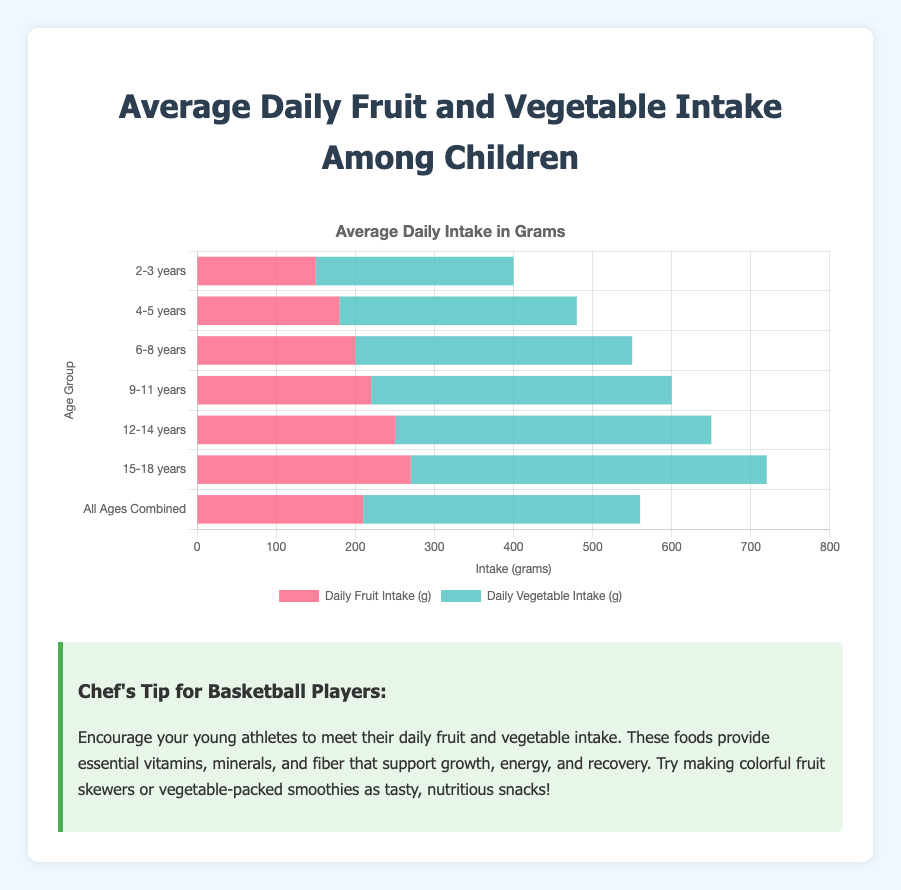What is the total daily intake (fruits and vegetables combined) for children aged 6-8 years? Sum the daily fruit intake (200 g) and daily vegetable intake (350 g) for children aged 6-8 years. 200 g + 350 g = 550 g
Answer: 550 g Which age group has the highest daily fruit intake? Check the daily fruit intake values for all age groups and identify the highest value, which is 270 g for the 15-18 years age group.
Answer: 15-18 years Between the 2-3 years and 4-5 years age groups, which has a higher vegetable intake? Compare the daily vegetable intake for the 2-3 years age group (250 g) and the 4-5 years age group (300 g). 300 g is greater than 250 g.
Answer: 4-5 years What is the visual difference in daily fruit intake between the 9-11 years and 12-14 years age groups? From the chart, compare the lengths of the bars representing fruit intake for 9-11 years (220 g) and 12-14 years (250 g). The difference is 250 g - 220 g = 30 g.
Answer: 30 g What is the average daily vegetable intake for all ages combined? The daily vegetable intake for all ages combined is given as 350 g.
Answer: 350 g Which age group's total daily intake (fruits and vegetables) is closest to 600 grams? Add the daily fruit and vegetable intake for each age group and compare the sums: 2-3 years = 400 g, 4-5 years = 480 g, 6-8 years = 550 g, 9-11 years = 600 g, 12-14 years = 650 g, 15-18 years = 720 g. 9-11 years total (600 g) is closest to 600 grams.
Answer: 9-11 years Is the daily fruit intake higher or lower than the daily vegetable intake for children aged 2-3 years? Compare the daily fruit intake (150 g) and vegetable intake (250 g) for the 2-3 years age group. 150 g is less than 250 g.
Answer: Lower How does the daily vegetable intake for children aged 15-18 years compare to the daily fruit intake for the same age group? Compare the daily fruit (270 g) and vegetable (450 g) intakes for the 15-18 years age group. 450 g is greater than 270 g.
Answer: Higher 